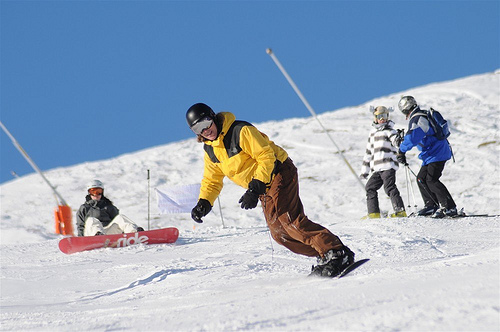Please transcribe the text in this image. ride 